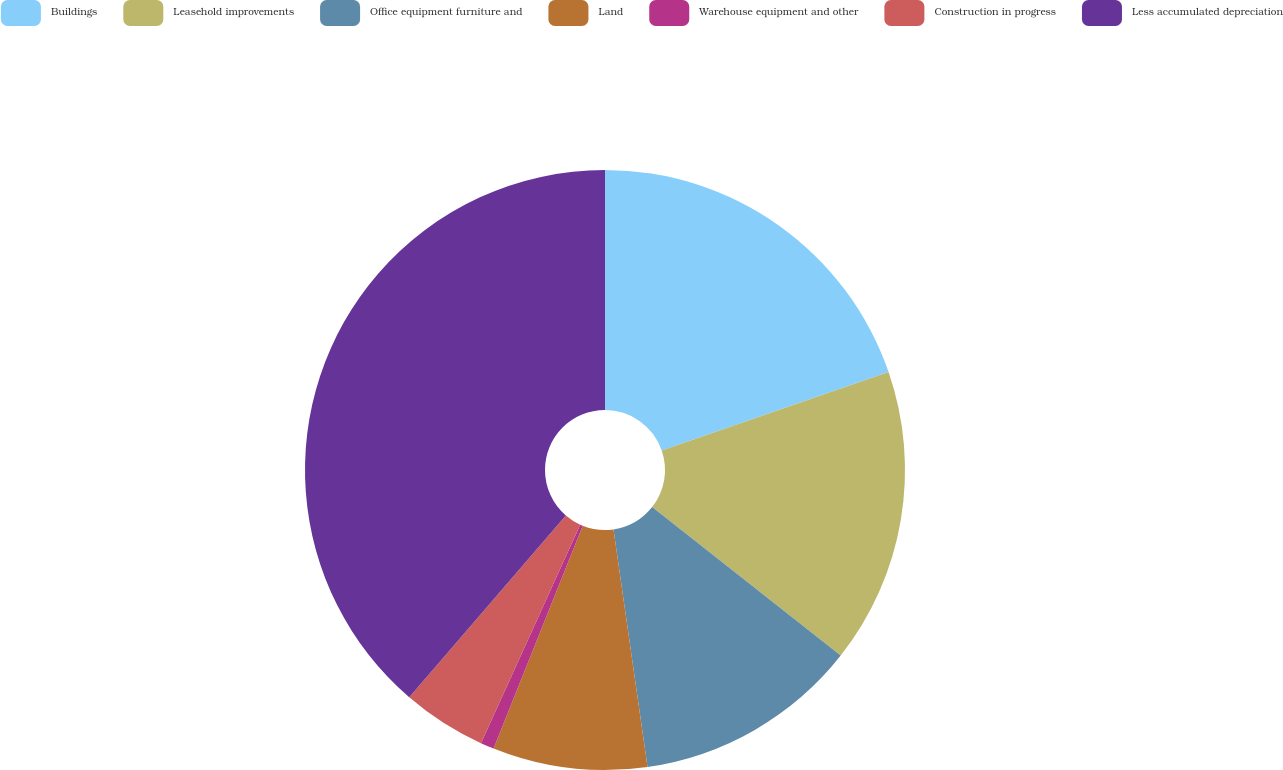Convert chart. <chart><loc_0><loc_0><loc_500><loc_500><pie_chart><fcel>Buildings<fcel>Leasehold improvements<fcel>Office equipment furniture and<fcel>Land<fcel>Warehouse equipment and other<fcel>Construction in progress<fcel>Less accumulated depreciation<nl><fcel>19.71%<fcel>15.91%<fcel>12.12%<fcel>8.32%<fcel>0.73%<fcel>4.53%<fcel>38.69%<nl></chart> 